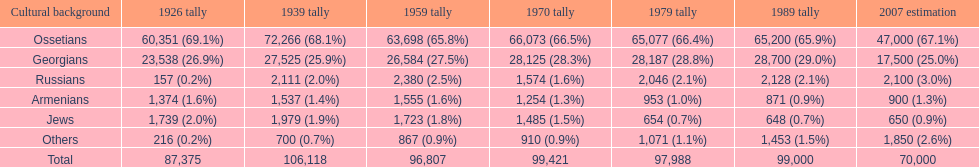What ethnicity is at the top? Ossetians. 